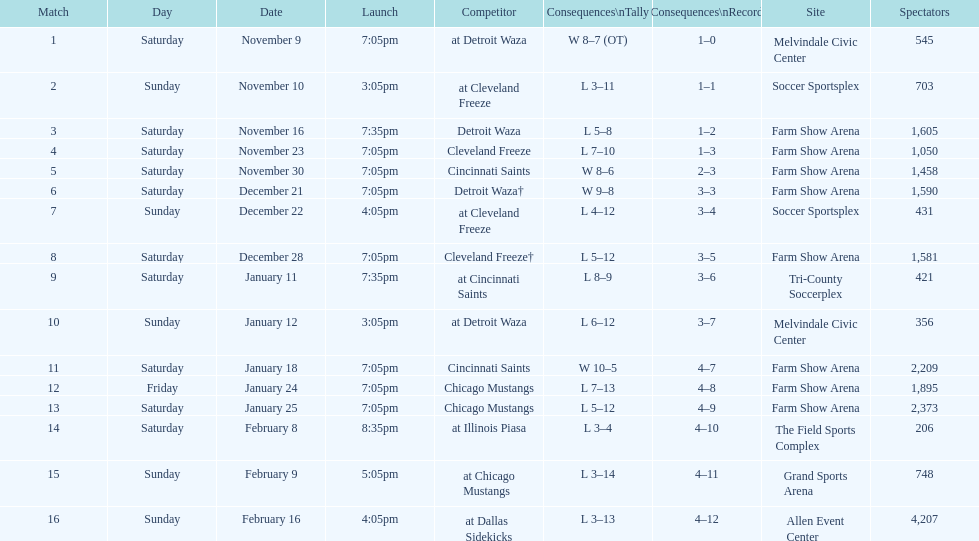How many times did the team play at home but did not win? 5. 